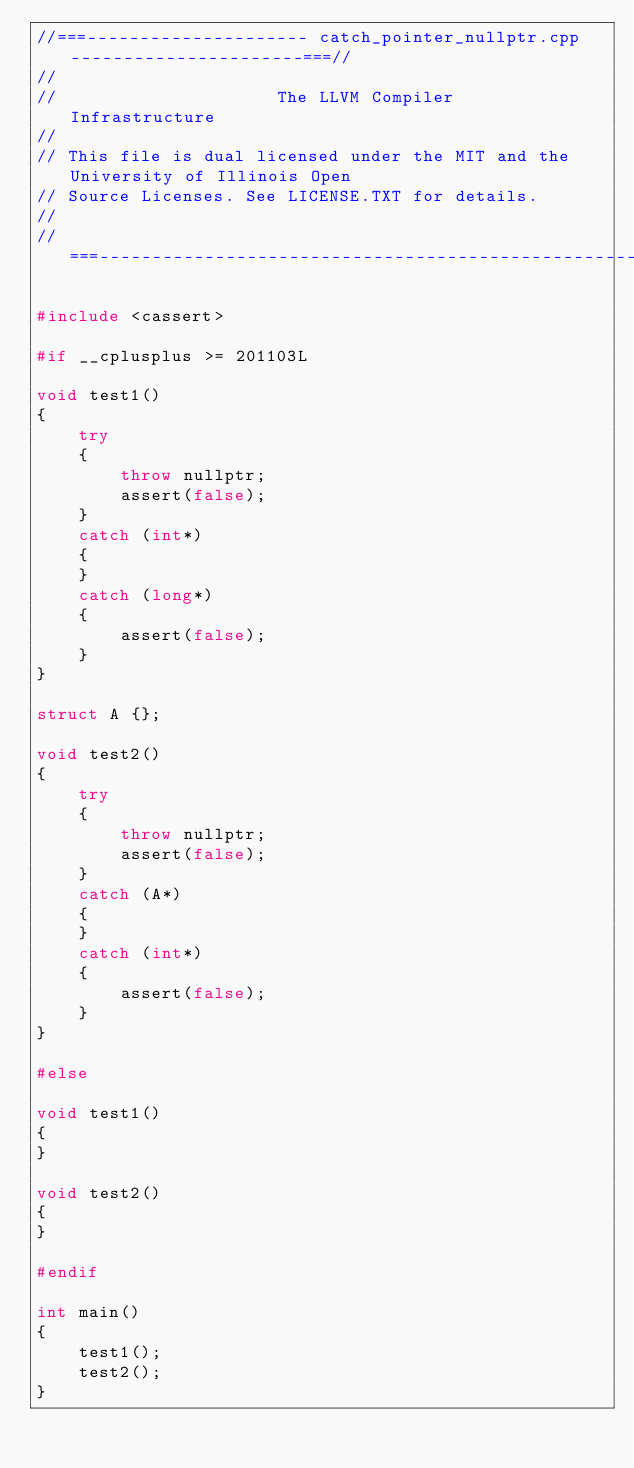<code> <loc_0><loc_0><loc_500><loc_500><_C++_>//===--------------------- catch_pointer_nullptr.cpp ----------------------===//
//
//                     The LLVM Compiler Infrastructure
//
// This file is dual licensed under the MIT and the University of Illinois Open
// Source Licenses. See LICENSE.TXT for details.
//
//===----------------------------------------------------------------------===//

#include <cassert>

#if __cplusplus >= 201103L

void test1()
{
    try
    {
        throw nullptr;
        assert(false);
    }
    catch (int*)
    {
    }
    catch (long*)
    {
        assert(false);
    }
}

struct A {};

void test2()
{
    try
    {
        throw nullptr;
        assert(false);
    }
    catch (A*)
    {
    }
    catch (int*)
    {
        assert(false);
    }
}

#else

void test1()
{
}

void test2()
{
}

#endif

int main()
{
    test1();
    test2();
}
</code> 